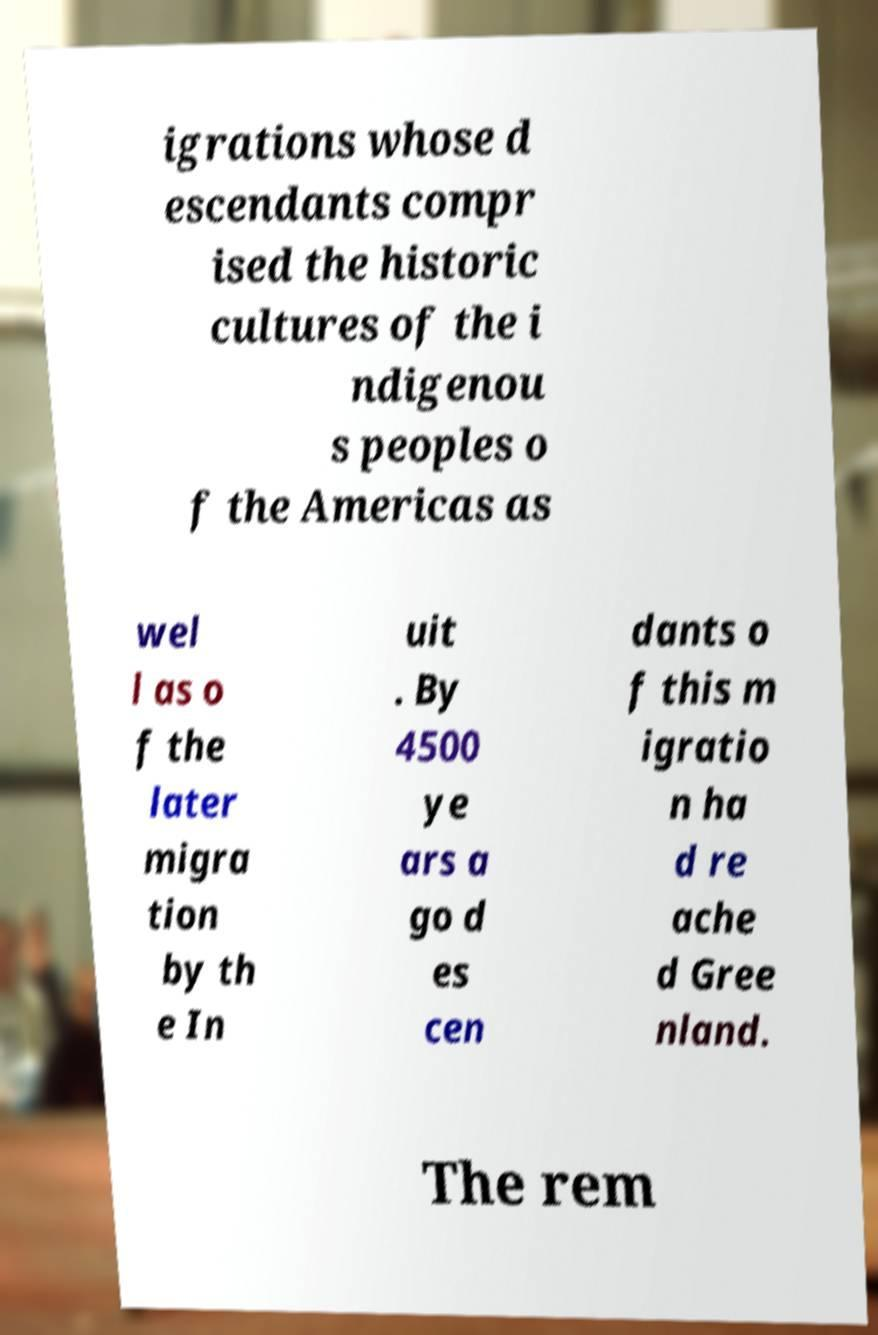Can you read and provide the text displayed in the image?This photo seems to have some interesting text. Can you extract and type it out for me? igrations whose d escendants compr ised the historic cultures of the i ndigenou s peoples o f the Americas as wel l as o f the later migra tion by th e In uit . By 4500 ye ars a go d es cen dants o f this m igratio n ha d re ache d Gree nland. The rem 